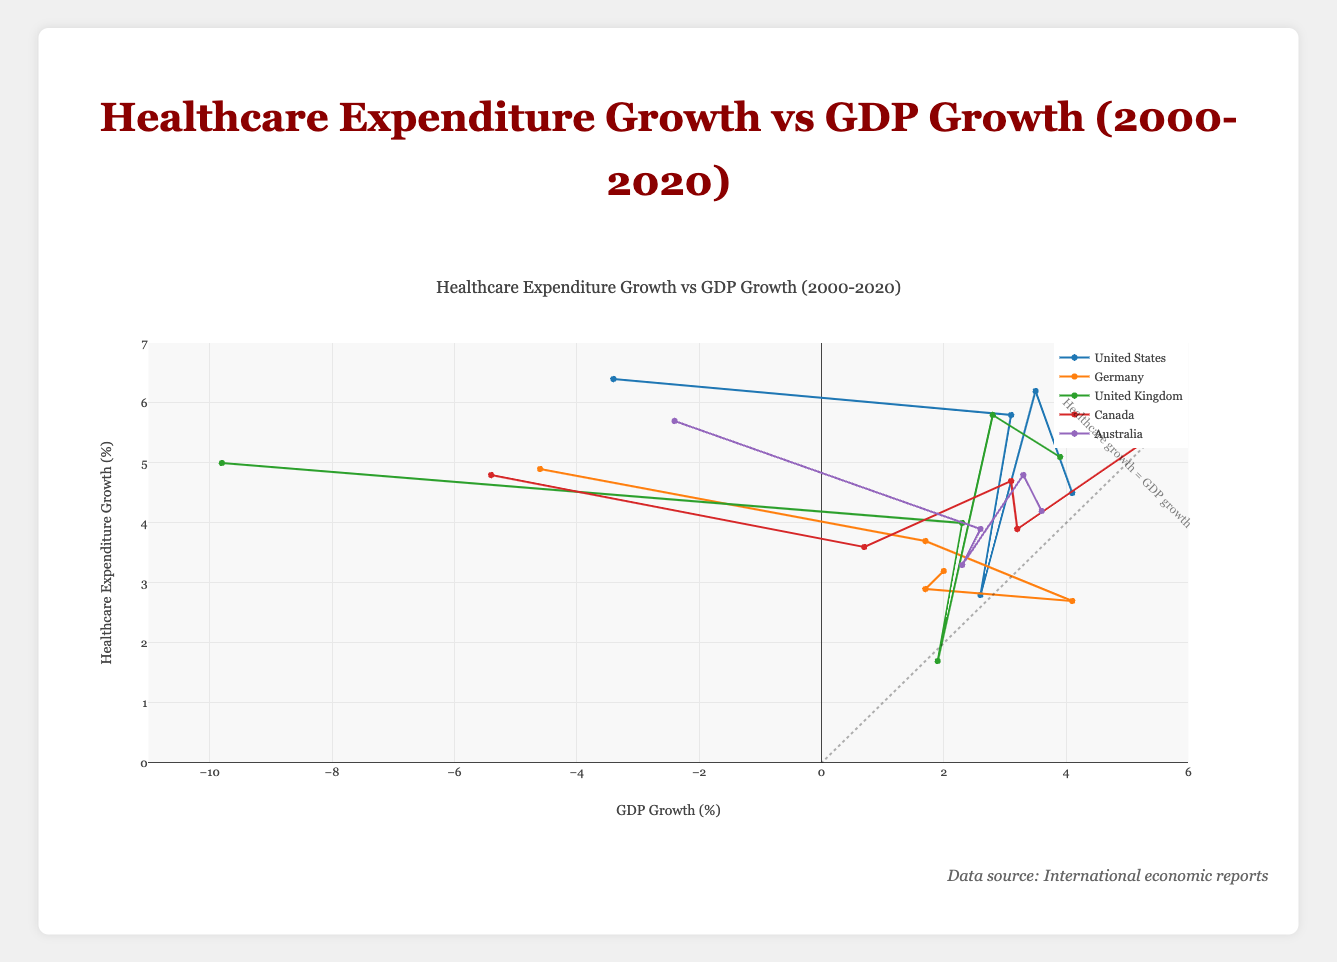Which country had the highest healthcare expenditure growth in 2020? The chart shows the healthcare expenditure growth for different countries. By looking at the y-axis value for 2020, we see that the United States had the highest growth at 6.4%.
Answer: United States Compare the GDP growth of Germany and the United Kingdom in 2020. Which one was higher? By examining the x-axis values for 2020 of both countries, Germany had a GDP growth of -4.6%, whereas the United Kingdom had a GDP growth of -9.8%. Thus, Germany's GDP growth was higher.
Answer: Germany What is the difference in healthcare expenditure growth between the United States and Australia in the year 2015? From the chart, we find the healthcare expenditure growth for the United States in 2015 was 5.8%, and for Australia, it was 3.9%. The difference is 5.8% - 3.9% = 1.9%.
Answer: 1.9% Which country had the largest decrease in GDP growth rate from 2015 to 2020? Comparing the GDP growth rate values from 2015 to 2020 for each country: United States (3.1% to -3.4%), Germany (1.7% to -4.6%), United Kingdom (2.3% to -9.8%), Canada (0.7% to -5.4%), and Australia (2.6% to -2.4%). The United Kingdom had the largest decrease of 2.3% - (-9.8%) = -12.1%.
Answer: United Kingdom By how much did Canada's healthcare expenditure growth change from 2010 to 2020? Canada's healthcare expenditure growth was 4.7% in 2010 and 4.8% in 2020. The change is 4.8% - 4.7% = 0.1%.
Answer: 0.1% What was the average GDP growth rate of Australia across all the years shown? Sum the GDP growth rates of Australia over the years (3.6% + 3.3% + 2.3% + 2.6% - 2.4%) = 9.4%. The average is 9.4% / 5 = 1.88%.
Answer: 1.88% Are there any years where healthcare expenditure growth and GDP growth of the United States are equal? Reviewing the plotted data points for the United States, there is no year where the healthcare expenditure growth and GDP growth are the same.
Answer: No Compare healthcare expenditure growth trends between Germany and Canada from 2000 to 2020. Who has a more stable growth pattern? Examining the trends, Germany's healthcare expenditure growth ranges from 2.7% to 4.9%, while Canada's ranges from 3.6% to 5.3%. Germany shows a more stable pattern with less variation.
Answer: Germany Which country showed a positive GDP growth in 2020? From the plot, none of the countries listed showed a positive GDP growth in 2020; all were negative.
Answer: None Determine which country experienced the most significant average healthcare expenditure growth over the period from 2000 to 2020. Calculate the average healthcare expenditure growth for each country:  
United States: (4.5 + 6.2 + 2.8 + 5.8 + 6.4) / 5 = 5.14  
Germany: (3.2 + 2.9 + 2.7 + 3.7 + 4.9) / 5 = 3.48  
United Kingdom: (5.1 + 5.8 + 1.7 + 4.0 + 5.0) / 5 = 4.32  
Canada: (5.3 + 3.9 + 4.7 + 3.6 + 4.8) / 5 = 4.46  
Australia: (4.2 + 4.8 + 3.3 + 3.9 + 5.7) / 5 = 4.38  
The United States had the highest average healthcare expenditure growth.
Answer: United States 